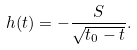<formula> <loc_0><loc_0><loc_500><loc_500>h ( t ) = - \frac { S } { \sqrt { t _ { 0 } - t } } .</formula> 